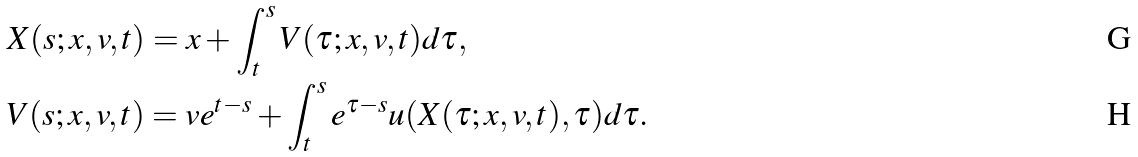Convert formula to latex. <formula><loc_0><loc_0><loc_500><loc_500>& X ( s ; x , v , t ) = x + \int _ { t } ^ { s } V ( \tau ; x , v , t ) d \tau , \\ & V ( s ; x , v , t ) = v e ^ { t - s } + \int _ { t } ^ { s } e ^ { \tau - s } u ( X ( \tau ; x , v , t ) , \tau ) d \tau .</formula> 